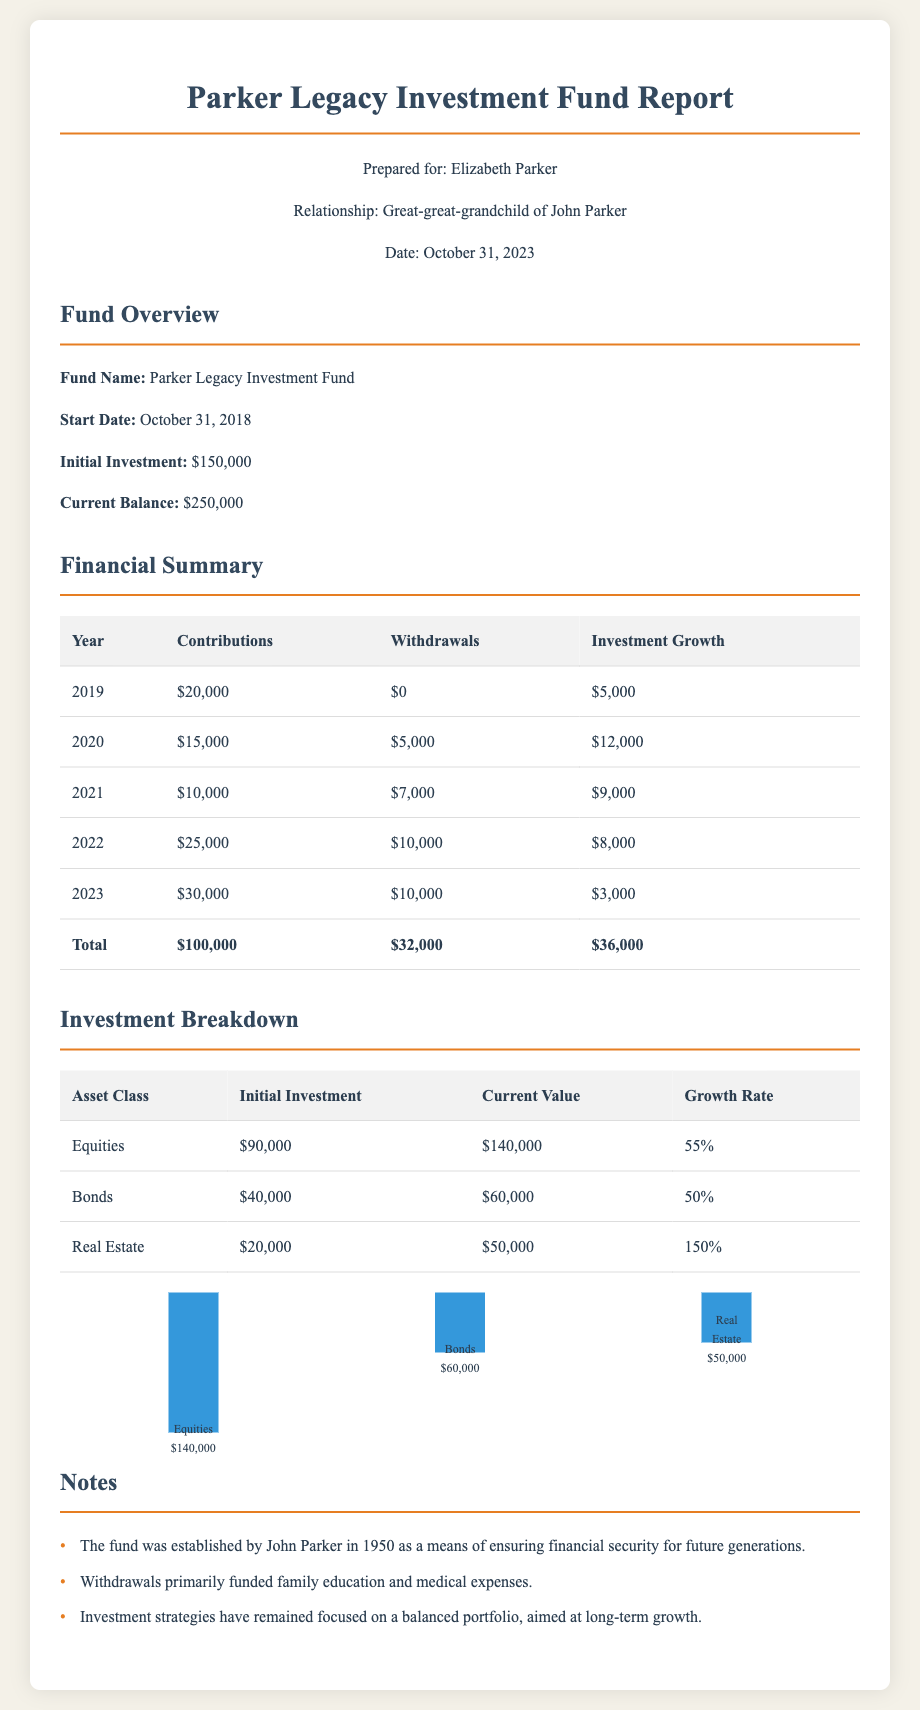What is the fund name? The fund name is mentioned in the fund overview section as "Parker Legacy Investment Fund."
Answer: Parker Legacy Investment Fund What is the initial investment amount? The initial investment amount is specified in the fund overview section as $150,000.
Answer: $150,000 What was the total of contributions over five years? The total contributions are listed in the financial summary table, which sums up to $100,000.
Answer: $100,000 How much was withdrawn in 2020? The amount withdrawn in 2020 is stated in the financial summary as $5,000.
Answer: $5,000 Which asset class had the highest growth rate? The growth rates for asset classes are compared in the investment breakdown, with "Real Estate" having the highest at 150%.
Answer: Real Estate What year saw the largest contribution? The financial summary indicates that the largest contributions were made in the year 2023, totaling $30,000.
Answer: 2023 What is the current balance of the fund? The current balance is provided in the fund overview section as $250,000.
Answer: $250,000 What percentage of the investment growth was achieved in 2021? The investment growth for 2021 is listed in the financial summary as $9,000.
Answer: $9,000 What year did the fund start? The start date of the fund is noted in the fund overview section as October 31, 2018.
Answer: October 31, 2018 